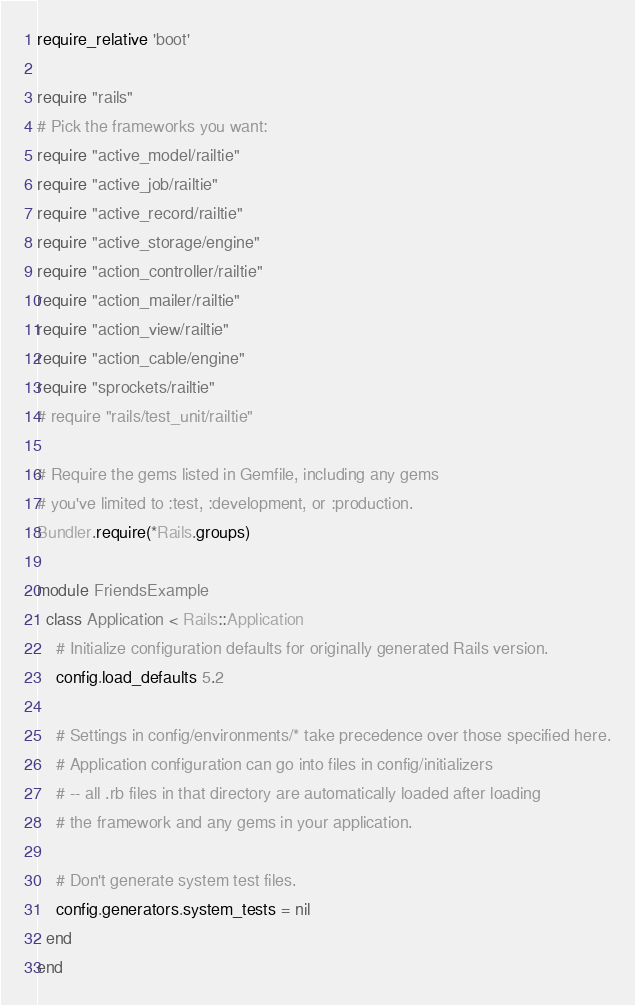Convert code to text. <code><loc_0><loc_0><loc_500><loc_500><_Ruby_>require_relative 'boot'

require "rails"
# Pick the frameworks you want:
require "active_model/railtie"
require "active_job/railtie"
require "active_record/railtie"
require "active_storage/engine"
require "action_controller/railtie"
require "action_mailer/railtie"
require "action_view/railtie"
require "action_cable/engine"
require "sprockets/railtie"
# require "rails/test_unit/railtie"

# Require the gems listed in Gemfile, including any gems
# you've limited to :test, :development, or :production.
Bundler.require(*Rails.groups)

module FriendsExample
  class Application < Rails::Application
    # Initialize configuration defaults for originally generated Rails version.
    config.load_defaults 5.2

    # Settings in config/environments/* take precedence over those specified here.
    # Application configuration can go into files in config/initializers
    # -- all .rb files in that directory are automatically loaded after loading
    # the framework and any gems in your application.

    # Don't generate system test files.
    config.generators.system_tests = nil
  end
end
</code> 